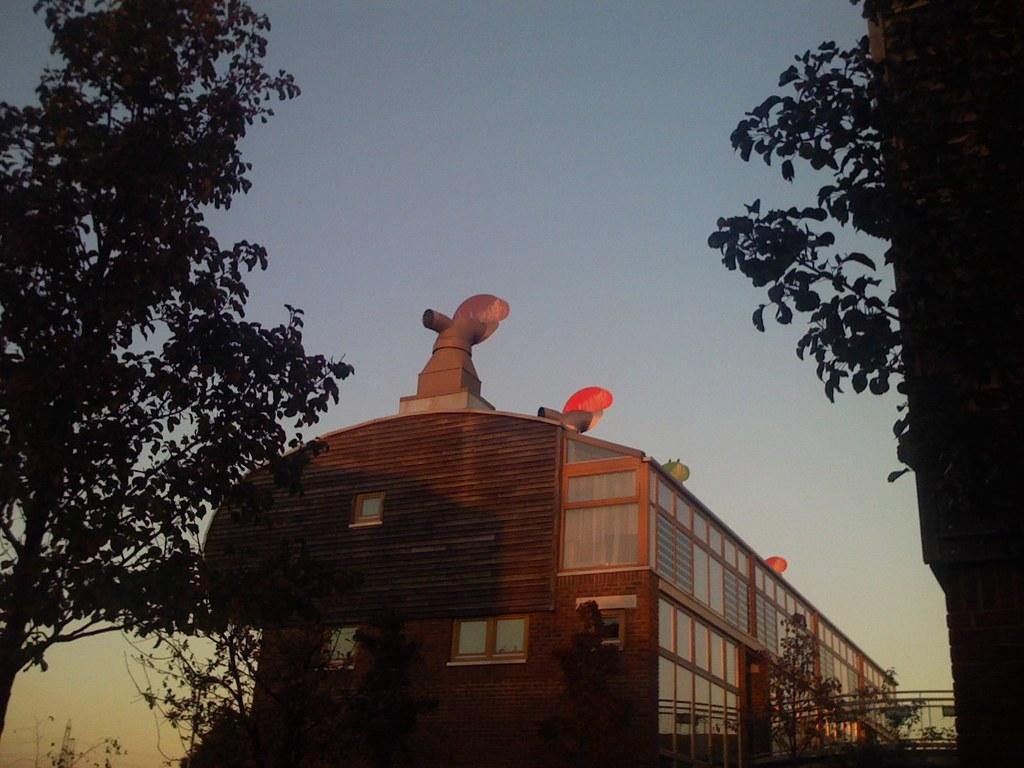What is the main subject in the middle of the image? There is a building in the middle of the image. What can be seen on either side of the building? There are trees on either side of the building. What is visible at the top of the image? The sky is visible at the top of the image. What caption is written on the building in the image? There is no caption visible on the building in the image. Can you tell me how many airplanes are parked at the airport in the image? There is no airport or airplanes present in the image; it features a building with trees on either side and a visible sky. 